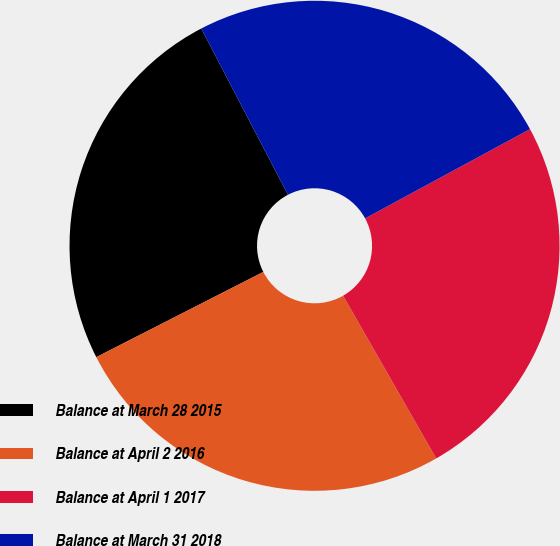<chart> <loc_0><loc_0><loc_500><loc_500><pie_chart><fcel>Balance at March 28 2015<fcel>Balance at April 2 2016<fcel>Balance at April 1 2017<fcel>Balance at March 31 2018<nl><fcel>24.86%<fcel>25.76%<fcel>24.63%<fcel>24.75%<nl></chart> 